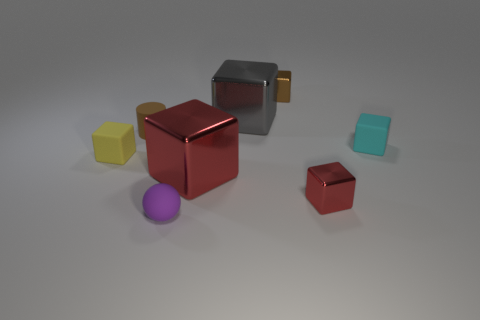What shape is the red metallic object that is the same size as the brown matte cylinder?
Provide a short and direct response. Cube. What number of small objects are both on the right side of the small purple sphere and in front of the small cylinder?
Your answer should be compact. 2. Are there fewer large objects that are on the left side of the yellow rubber object than small brown objects?
Provide a short and direct response. Yes. Are there any brown matte cylinders of the same size as the matte ball?
Give a very brief answer. Yes. What is the color of the big thing that is the same material as the big red cube?
Offer a terse response. Gray. There is a red shiny object behind the small red thing; how many rubber blocks are in front of it?
Provide a short and direct response. 0. There is a small object that is in front of the tiny rubber cylinder and on the left side of the tiny purple sphere; what material is it?
Keep it short and to the point. Rubber. Is the shape of the metallic object behind the big gray object the same as  the tiny purple rubber object?
Your response must be concise. No. Are there fewer cyan blocks than red blocks?
Ensure brevity in your answer.  Yes. How many other small matte spheres have the same color as the tiny matte ball?
Offer a very short reply. 0. 